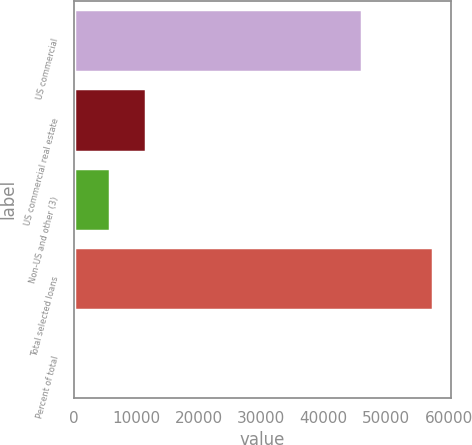Convert chart to OTSL. <chart><loc_0><loc_0><loc_500><loc_500><bar_chart><fcel>US commercial<fcel>US commercial real estate<fcel>Non-US and other (3)<fcel>Total selected loans<fcel>Percent of total<nl><fcel>46114<fcel>11517.2<fcel>5766.1<fcel>57526<fcel>15<nl></chart> 